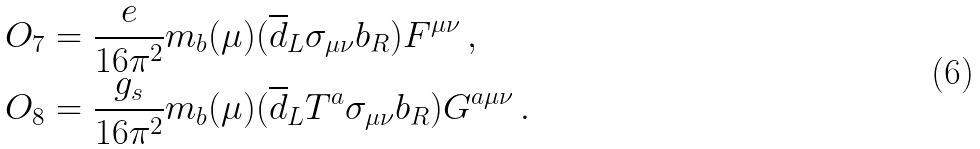Convert formula to latex. <formula><loc_0><loc_0><loc_500><loc_500>O _ { 7 } & = \frac { e } { 1 6 \pi ^ { 2 } } m _ { b } ( \mu ) ( \overline { d } _ { L } \sigma _ { \mu \nu } b _ { R } ) F ^ { \mu \nu } \, , \\ O _ { 8 } & = \frac { g _ { s } } { 1 6 \pi ^ { 2 } } m _ { b } ( \mu ) ( \overline { d } _ { L } T ^ { a } \sigma _ { \mu \nu } b _ { R } ) G ^ { a \mu \nu } \, .</formula> 